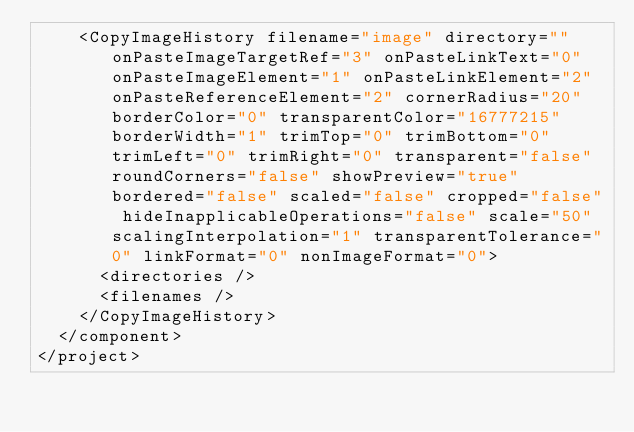Convert code to text. <code><loc_0><loc_0><loc_500><loc_500><_XML_>    <CopyImageHistory filename="image" directory="" onPasteImageTargetRef="3" onPasteLinkText="0" onPasteImageElement="1" onPasteLinkElement="2" onPasteReferenceElement="2" cornerRadius="20" borderColor="0" transparentColor="16777215" borderWidth="1" trimTop="0" trimBottom="0" trimLeft="0" trimRight="0" transparent="false" roundCorners="false" showPreview="true" bordered="false" scaled="false" cropped="false" hideInapplicableOperations="false" scale="50" scalingInterpolation="1" transparentTolerance="0" linkFormat="0" nonImageFormat="0">
      <directories />
      <filenames />
    </CopyImageHistory>
  </component>
</project></code> 